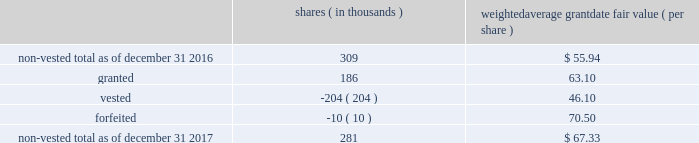The table below summarizes activity of rsus with performance conditions for the year ended december 31 , shares ( in thousands ) weighted average grant date fair value ( per share ) .
As of december 31 , 2017 , $ 6 million of total unrecognized compensation cost related to the nonvested rsus , with and without performance conditions , is expected to be recognized over the weighted-average remaining life of 1.5 years .
The total fair value of rsus , with and without performance conditions , vested was $ 16 million , $ 14 million and $ 12 million for the years ended december 31 , 2017 , 2016 and 2015 , respectively .
If dividends are paid with respect to shares of the company 2019s common stock before the rsus are distributed , the company credits a liability for the value of the dividends that would have been paid if the rsus were shares of company common stock .
When the rsus are distributed , the company pays the participant a lump sum cash payment equal to the value of the dividend equivalents accrued .
The company accrued dividend equivalents totaling less than $ 1 million , $ 1 million and $ 1 million to accumulated deficit in the accompanying consolidated statements of changes in stockholders 2019 equity for the years ended december 31 , 2017 , 2016 and 2015 , respectively .
Employee stock purchase plan the company maintains a nonqualified employee stock purchase plan ( the 201cespp 201d ) through which employee participants may use payroll deductions to acquire company common stock at the lesser of 90% ( 90 % ) of the fair market value of the common stock at either the beginning or the end of a three-month purchase period .
On february 15 , 2017 , the board adopted the american water works company , inc .
And its designated subsidiaries 2017 nonqualified employee stock purchase plan , which was approved by stockholders on may 12 , 2017 and took effect on august 5 , 2017 .
The prior plan was terminated as to new purchases of company stock effective august 31 , 2017 .
As of december 31 , 2017 , there were 2.0 million shares of common stock reserved for issuance under the espp .
The espp is considered compensatory .
During the years ended december 31 , 2017 , 2016 and 2015 , the company issued 93 thousand , 93 thousand and 98 thousand shares , respectively , under the espp. .
On december 31 , 2017 what is the estimated unrecognized compensation cost related to the non vested rsus , with and without performance conditions , is expected to be recognized as of december 31 , 2018 in millions? 
Rationale: the of total unrecognized compensation cost related to the nonvested rsus , with and without performance conditions , is expected to be recognized is 6 millon to be recognized over 1.5 years , thus the annual amount is equal to 6/1.5=4
Computations: (6 / 1.5)
Answer: 4.0. 